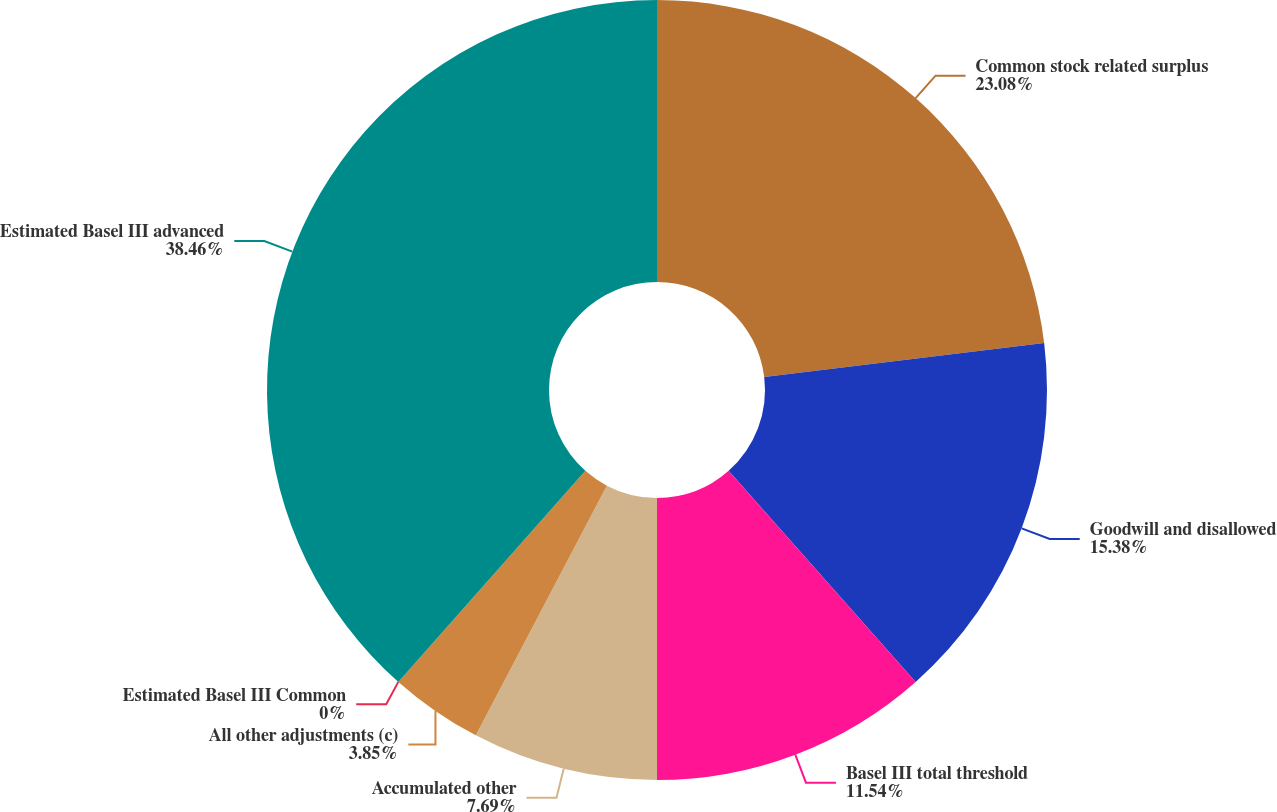Convert chart. <chart><loc_0><loc_0><loc_500><loc_500><pie_chart><fcel>Common stock related surplus<fcel>Goodwill and disallowed<fcel>Basel III total threshold<fcel>Accumulated other<fcel>All other adjustments (c)<fcel>Estimated Basel III Common<fcel>Estimated Basel III advanced<nl><fcel>23.08%<fcel>15.38%<fcel>11.54%<fcel>7.69%<fcel>3.85%<fcel>0.0%<fcel>38.46%<nl></chart> 